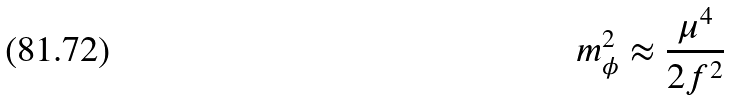<formula> <loc_0><loc_0><loc_500><loc_500>m _ { \phi } ^ { 2 } \approx \frac { \mu ^ { 4 } } { 2 f ^ { 2 } }</formula> 